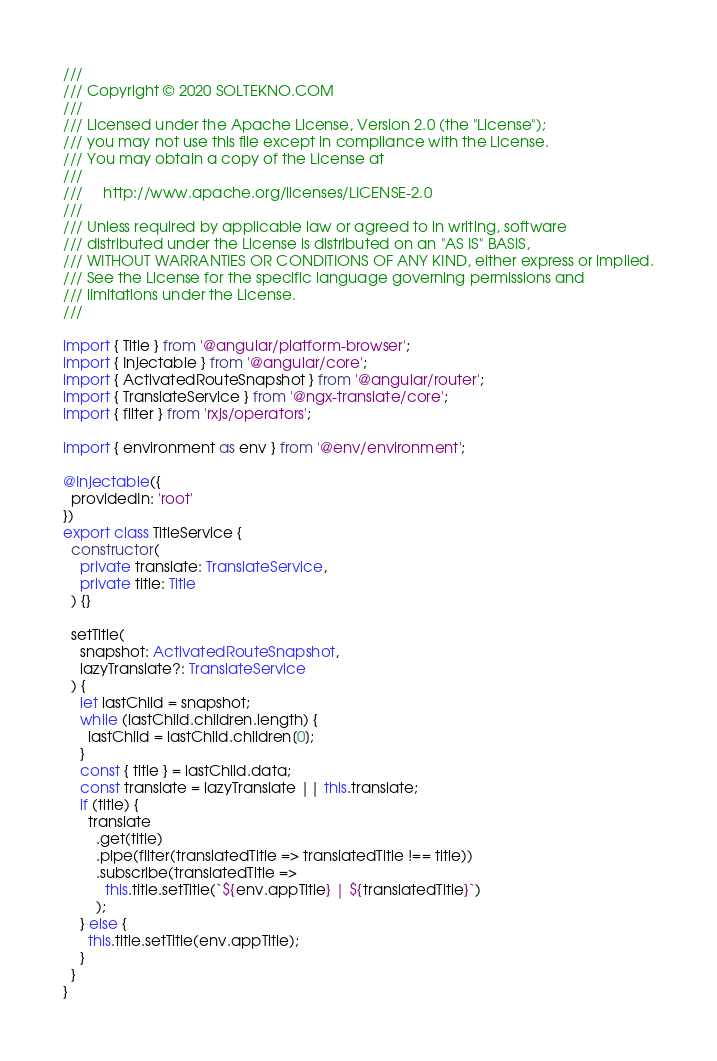Convert code to text. <code><loc_0><loc_0><loc_500><loc_500><_TypeScript_>///
/// Copyright © 2020 SOLTEKNO.COM
///
/// Licensed under the Apache License, Version 2.0 (the "License");
/// you may not use this file except in compliance with the License.
/// You may obtain a copy of the License at
///
///     http://www.apache.org/licenses/LICENSE-2.0
///
/// Unless required by applicable law or agreed to in writing, software
/// distributed under the License is distributed on an "AS IS" BASIS,
/// WITHOUT WARRANTIES OR CONDITIONS OF ANY KIND, either express or implied.
/// See the License for the specific language governing permissions and
/// limitations under the License.
///

import { Title } from '@angular/platform-browser';
import { Injectable } from '@angular/core';
import { ActivatedRouteSnapshot } from '@angular/router';
import { TranslateService } from '@ngx-translate/core';
import { filter } from 'rxjs/operators';

import { environment as env } from '@env/environment';

@Injectable({
  providedIn: 'root'
})
export class TitleService {
  constructor(
    private translate: TranslateService,
    private title: Title
  ) {}

  setTitle(
    snapshot: ActivatedRouteSnapshot,
    lazyTranslate?: TranslateService
  ) {
    let lastChild = snapshot;
    while (lastChild.children.length) {
      lastChild = lastChild.children[0];
    }
    const { title } = lastChild.data;
    const translate = lazyTranslate || this.translate;
    if (title) {
      translate
        .get(title)
        .pipe(filter(translatedTitle => translatedTitle !== title))
        .subscribe(translatedTitle =>
          this.title.setTitle(`${env.appTitle} | ${translatedTitle}`)
        );
    } else {
      this.title.setTitle(env.appTitle);
    }
  }
}
</code> 